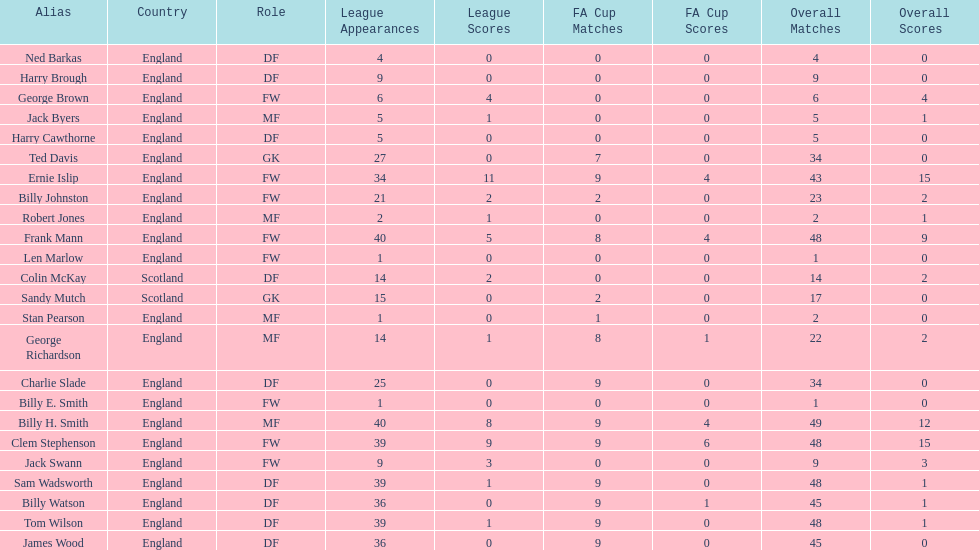What is the first name listed? Ned Barkas. 